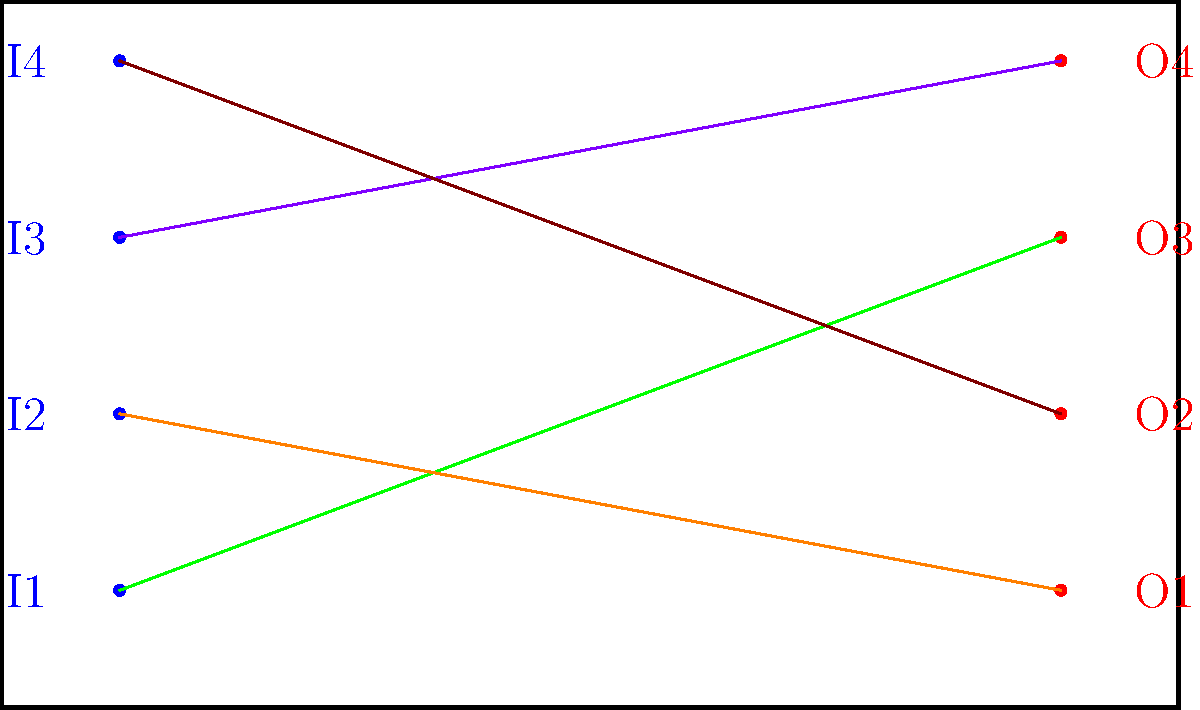In the given patch bay diagram, how many cross-connections are there between input and output jacks? To determine the number of cross-connections in the patch bay diagram, we need to follow these steps:

1. Identify the input jacks: There are 4 input jacks labeled I1, I2, I3, and I4 on the left side of the patch bay.

2. Identify the output jacks: There are 4 output jacks labeled O1, O2, O3, and O4 on the right side of the patch bay.

3. Count the connections:
   - Green cable: Connects I1 to O3
   - Orange cable: Connects I2 to O1
   - Purple cable: Connects I3 to O4
   - Brown cable: Connects I4 to O2

4. Determine cross-connections: A cross-connection occurs when an input jack is not connected to its corresponding output jack (e.g., I1 to O1, I2 to O2, etc.).

5. Count cross-connections:
   - I1 to O3: Cross-connection
   - I2 to O1: Cross-connection
   - I3 to O4: Cross-connection
   - I4 to O2: Cross-connection

Therefore, all 4 connections in the diagram are cross-connections.
Answer: 4 